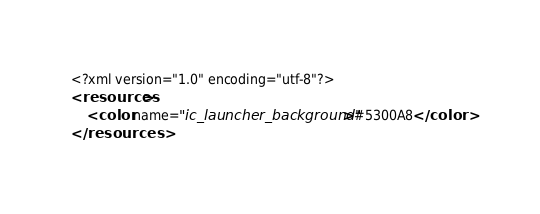Convert code to text. <code><loc_0><loc_0><loc_500><loc_500><_XML_><?xml version="1.0" encoding="utf-8"?>
<resources>
    <color name="ic_launcher_background">#5300A8</color>
</resources></code> 